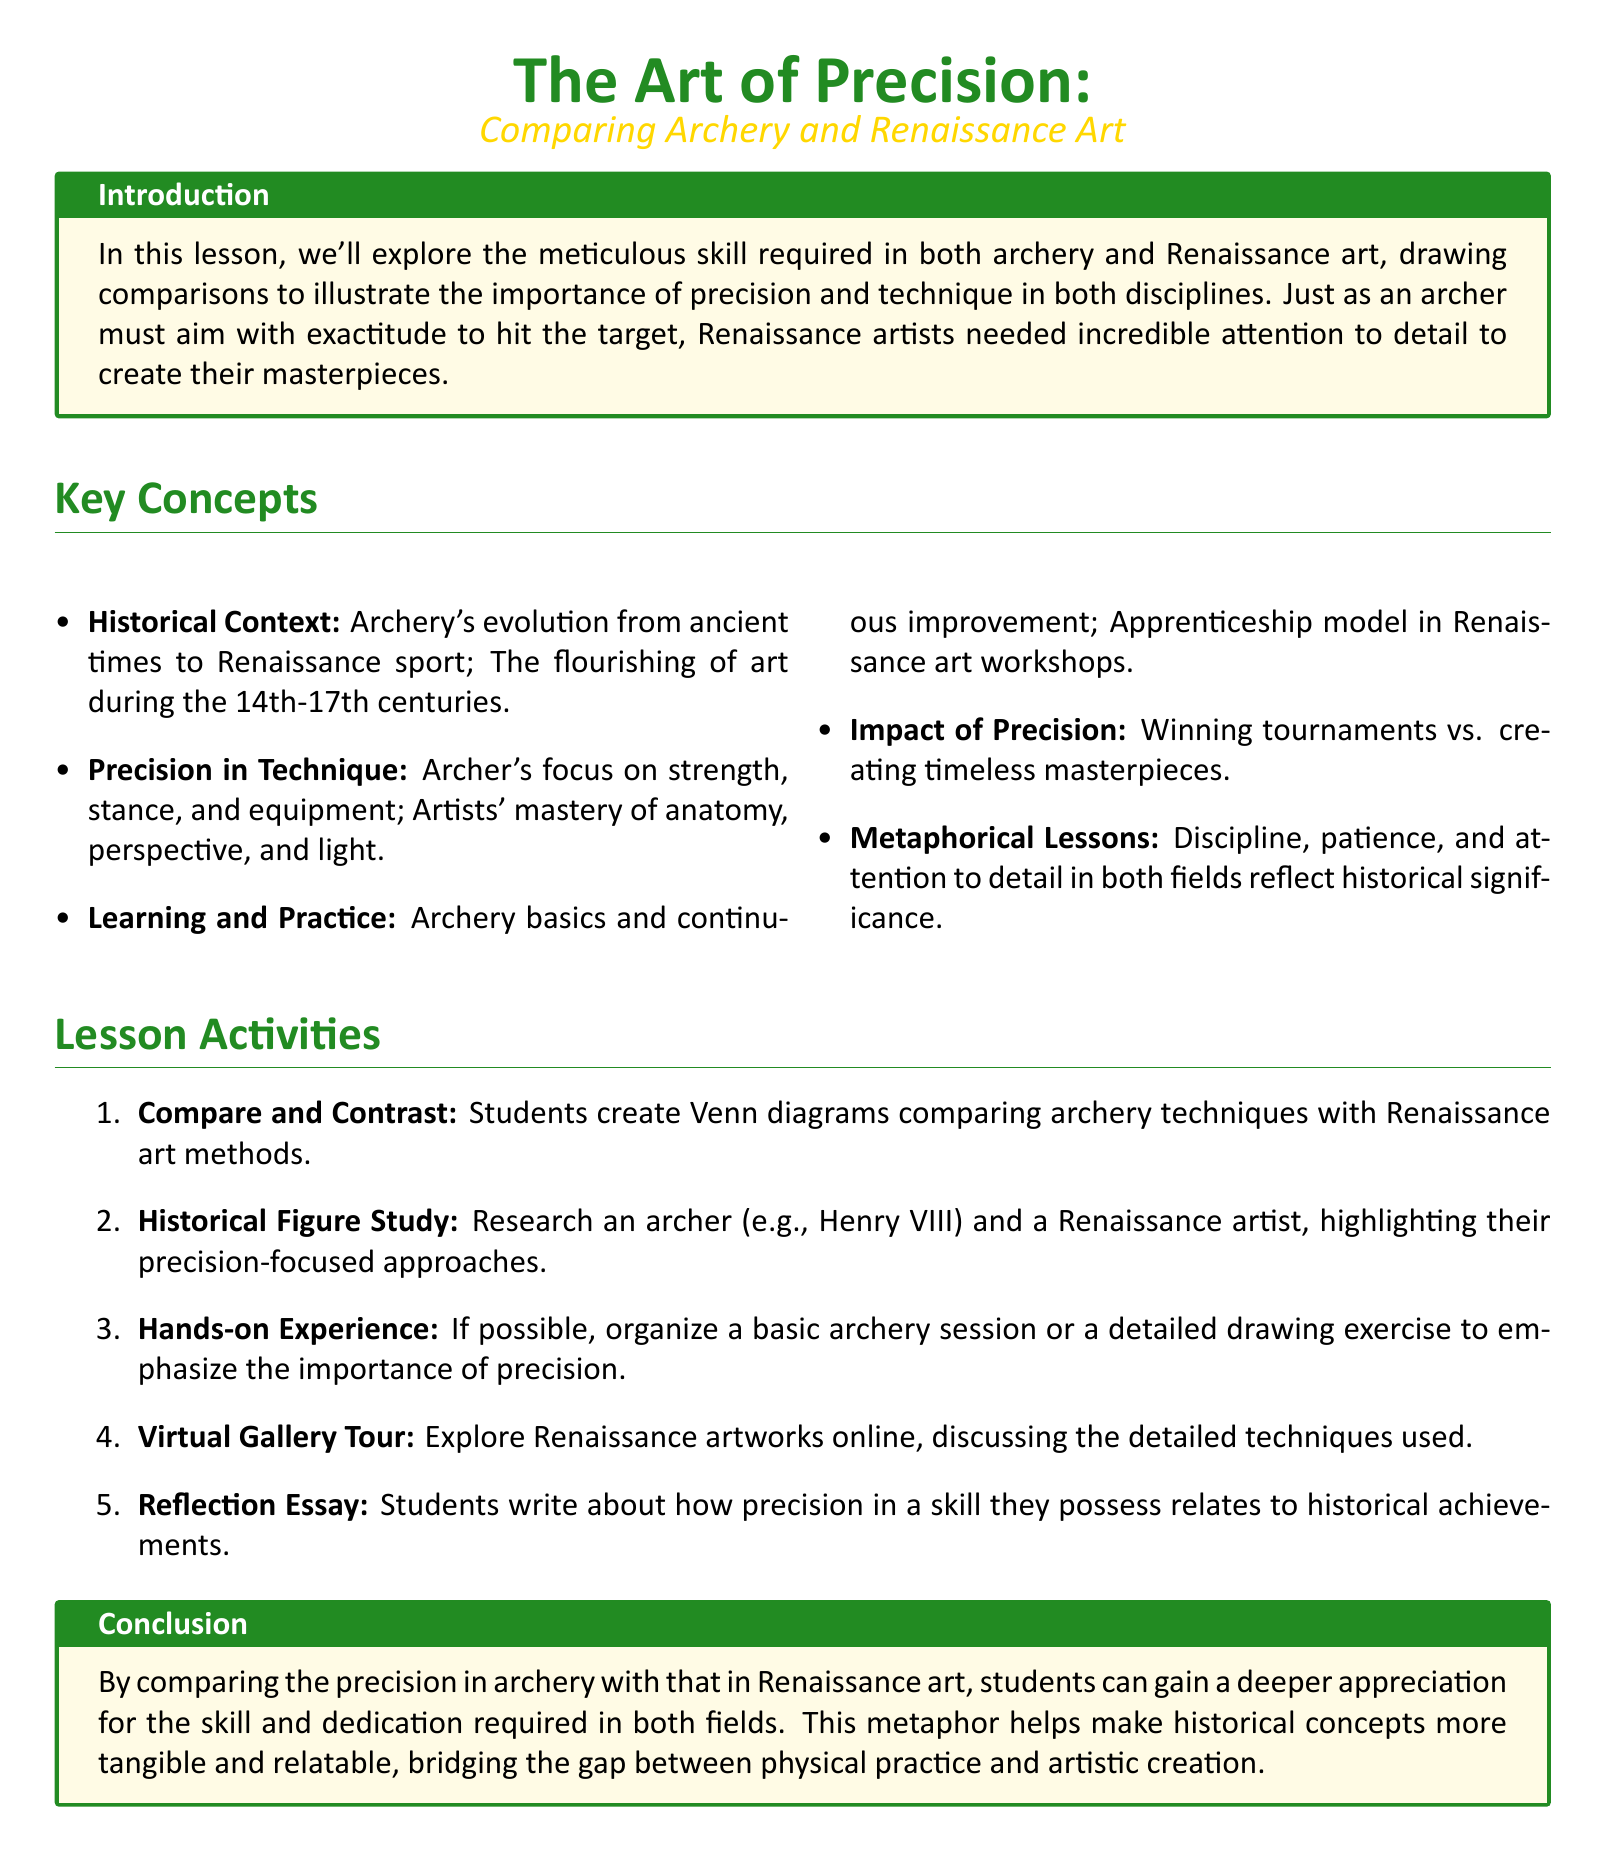What is the title of the lesson plan? The title of the lesson plan is prominently displayed at the top of the document.
Answer: The Art of Precision: Comparing Archery and Renaissance Art What are the key historical contexts covered in the lesson? The document lists the historical contexts as parts of a bullet point list under the key concepts section.
Answer: Archery's evolution from ancient times to Renaissance sport; The flourishing of art during the 14th-17th centuries How many lesson activities are included in the plan? The number of lesson activities can be found in the enumerated list under the lesson activities section.
Answer: Five Name one aspect of precision discussed in archery. The document lists several aspects of precision in archery, under the key concepts section.
Answer: Strength What metaphorical lessons are highlighted in the document? The metaphorical lessons are part of the key concepts section and are summarized.
Answer: Discipline, patience, and attention to detail Which historical figure is suggested for a study in the lesson plan? The name of the historical figure can be found in the activities section related to the historical figure study.
Answer: Henry VIII What type of experience is mentioned for hands-on learning? The document describes the nature of the hands-on experience in the lesson activities section.
Answer: Basic archery session or a detailed drawing exercise What does the conclusion of the document emphasize? The conclusion encapsulates the main takeaway regarding the comparison made in the document.
Answer: Appreciation for the skill and dedication required in both fields 